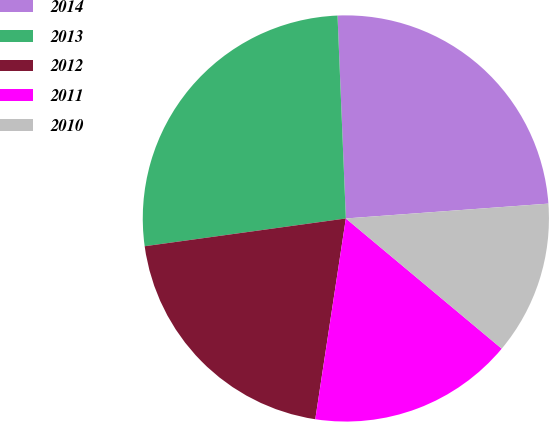Convert chart to OTSL. <chart><loc_0><loc_0><loc_500><loc_500><pie_chart><fcel>2014<fcel>2013<fcel>2012<fcel>2011<fcel>2010<nl><fcel>24.49%<fcel>26.53%<fcel>20.41%<fcel>16.33%<fcel>12.24%<nl></chart> 